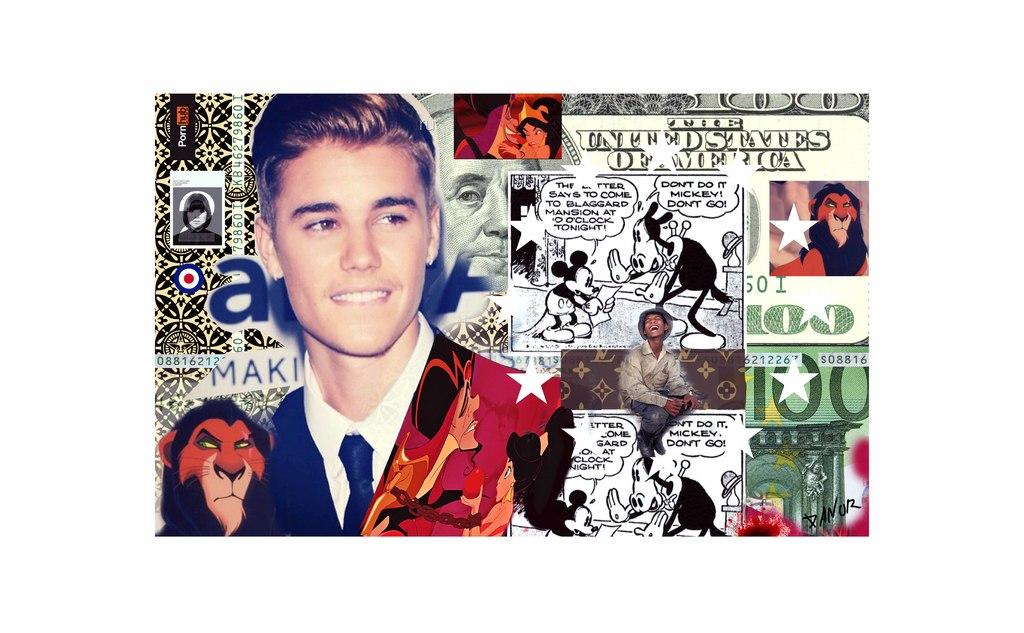Who is present in the image? There is a man in the image. What is the man wearing? The man is wearing a suit. What can be seen on the wall in the image? There is a poster in the image. What type of images are on the poster? The poster has cartoon images on it. What else is on the poster besides the images? There is text or matter written on the poster. What type of yarn is being used to create the cartoon images on the poster? There is no yarn present in the image; the cartoon images on the poster are likely created using ink or digital methods. 